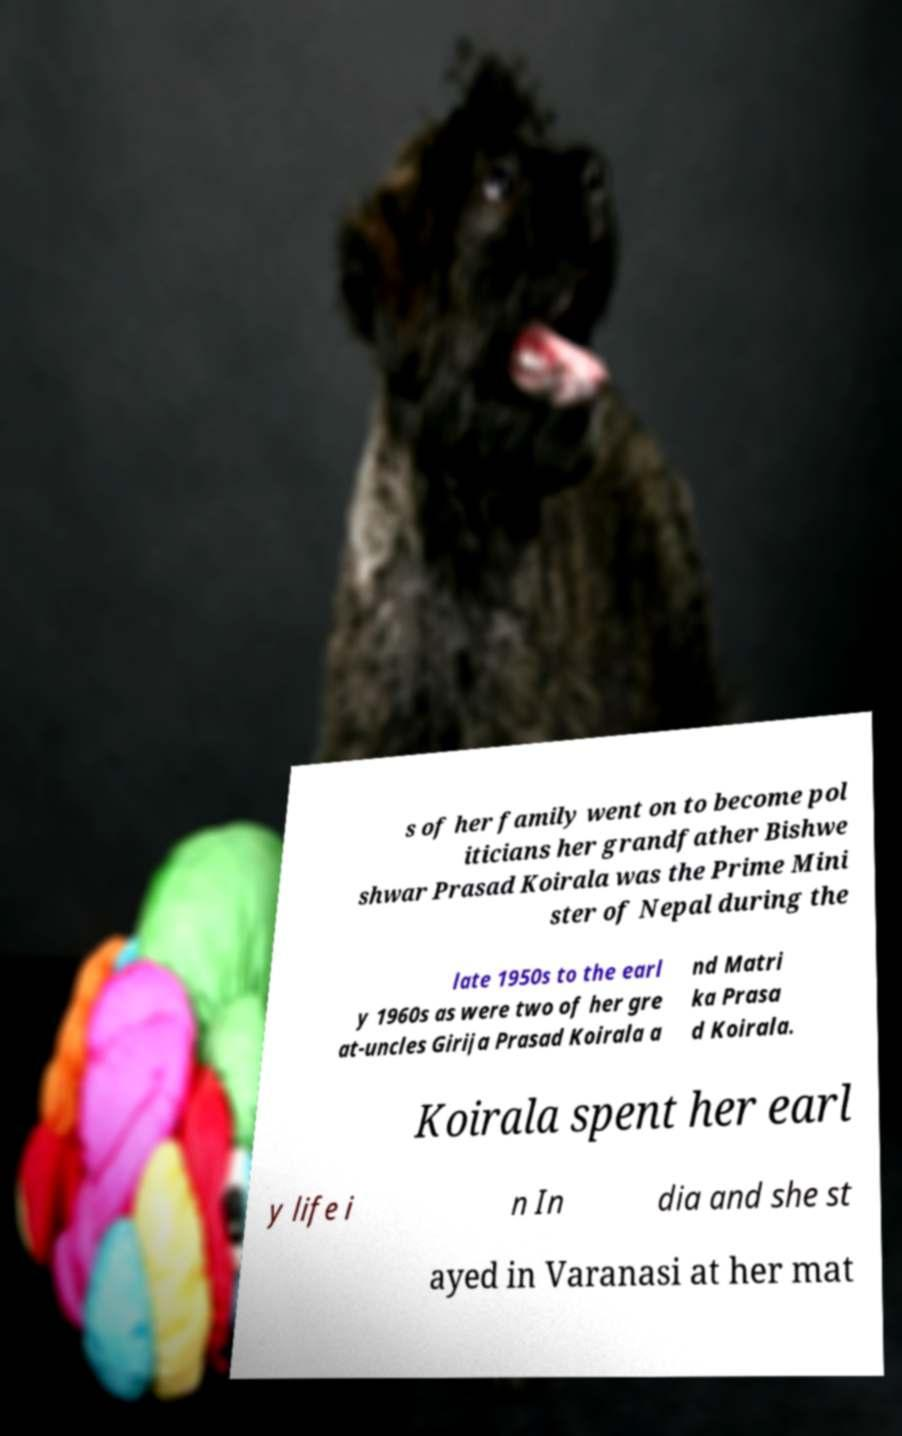Can you accurately transcribe the text from the provided image for me? s of her family went on to become pol iticians her grandfather Bishwe shwar Prasad Koirala was the Prime Mini ster of Nepal during the late 1950s to the earl y 1960s as were two of her gre at-uncles Girija Prasad Koirala a nd Matri ka Prasa d Koirala. Koirala spent her earl y life i n In dia and she st ayed in Varanasi at her mat 